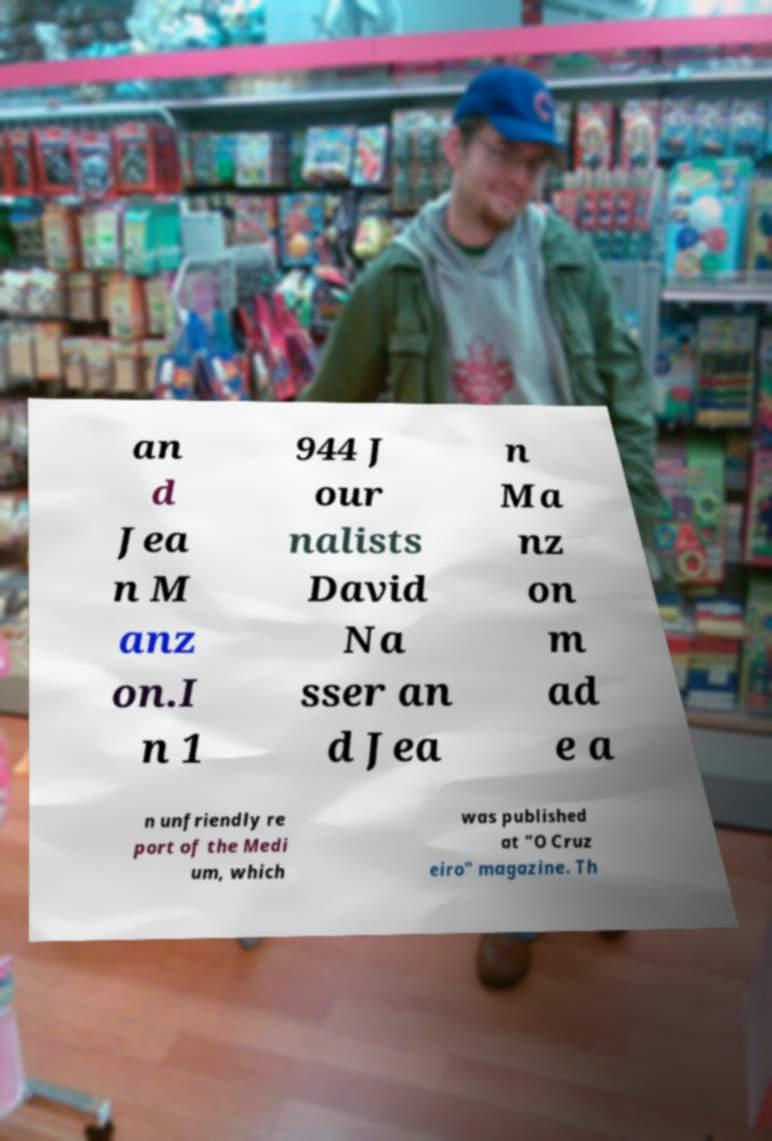Could you extract and type out the text from this image? an d Jea n M anz on.I n 1 944 J our nalists David Na sser an d Jea n Ma nz on m ad e a n unfriendly re port of the Medi um, which was published at "O Cruz eiro" magazine. Th 